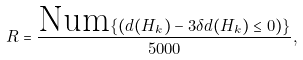Convert formula to latex. <formula><loc_0><loc_0><loc_500><loc_500>R = \frac { \text {Num} \{ ( d ( H _ { k } ) - 3 \delta d ( H _ { k } ) \leq 0 ) \} } { 5 0 0 0 } ,</formula> 